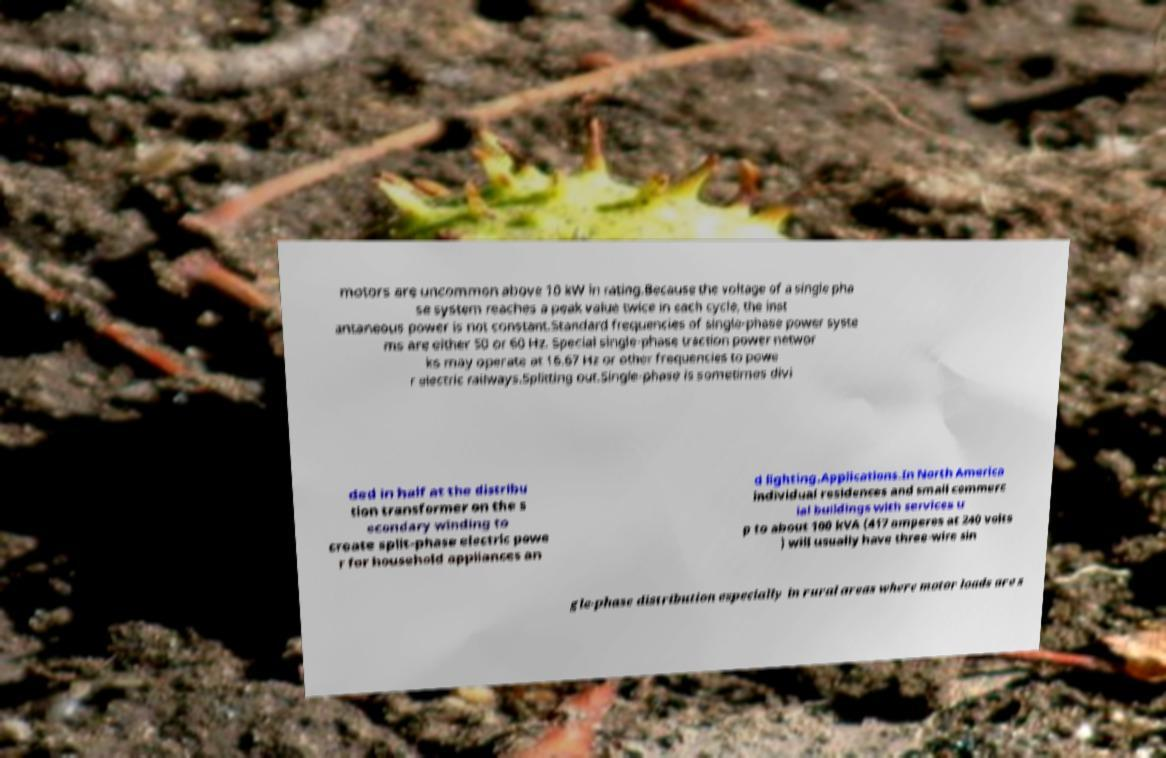There's text embedded in this image that I need extracted. Can you transcribe it verbatim? motors are uncommon above 10 kW in rating.Because the voltage of a single pha se system reaches a peak value twice in each cycle, the inst antaneous power is not constant.Standard frequencies of single-phase power syste ms are either 50 or 60 Hz. Special single-phase traction power networ ks may operate at 16.67 Hz or other frequencies to powe r electric railways.Splitting out.Single-phase is sometimes divi ded in half at the distribu tion transformer on the s econdary winding to create split-phase electric powe r for household appliances an d lighting.Applications.In North America individual residences and small commerc ial buildings with services u p to about 100 kVA (417 amperes at 240 volts ) will usually have three-wire sin gle-phase distribution especially in rural areas where motor loads are s 